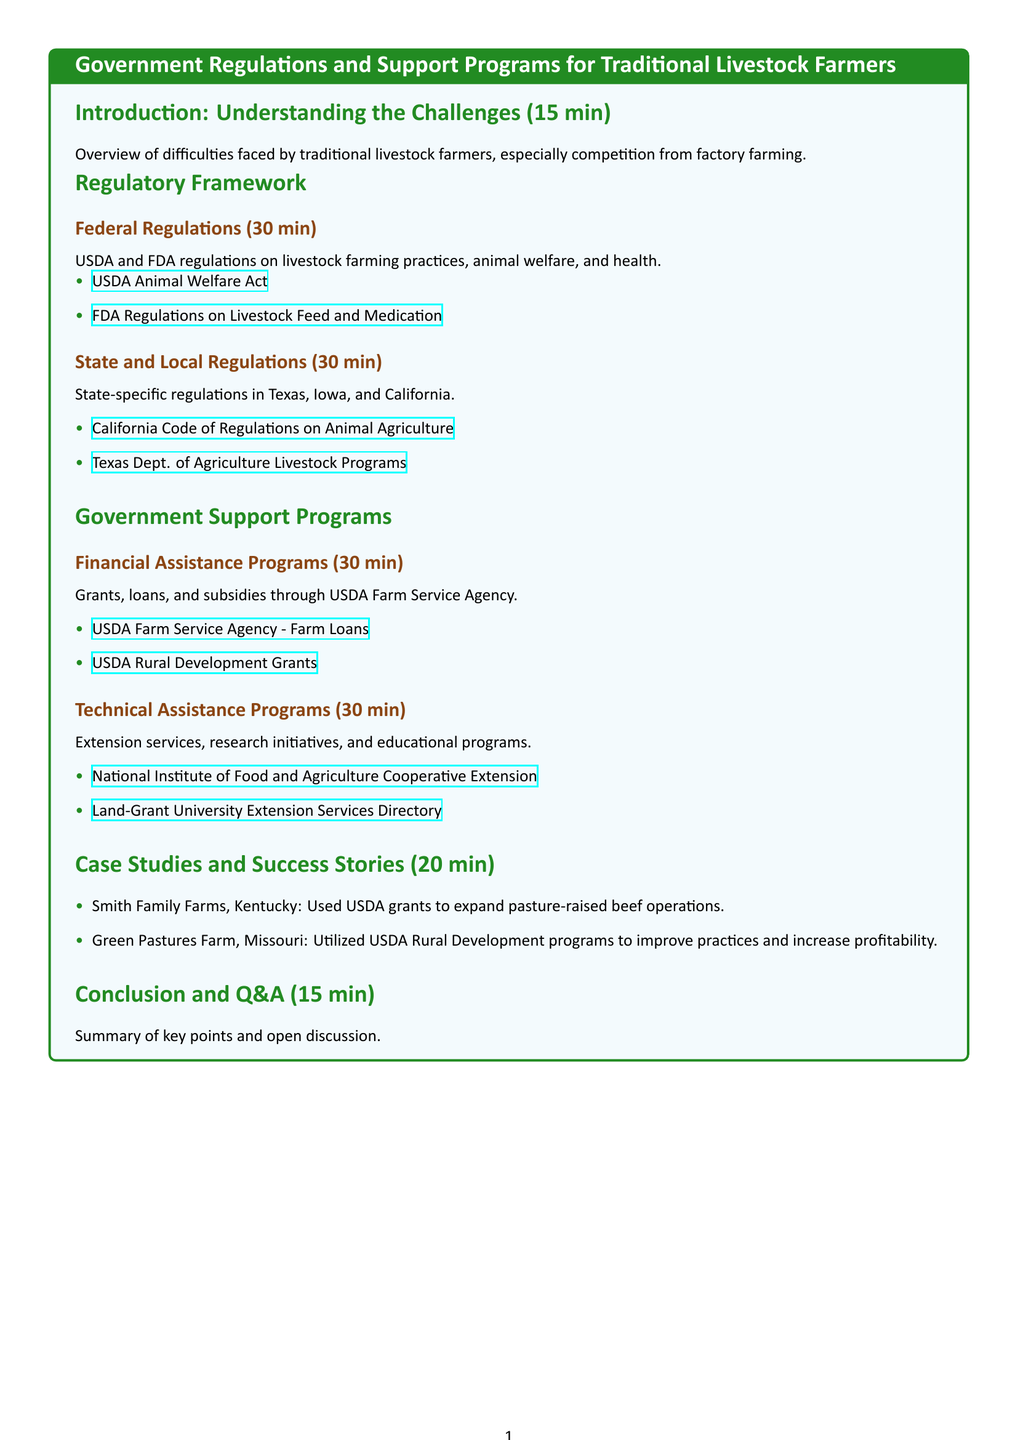What are the USDA regulations on livestock farming? This refers to the USDA regulations mentioned in the document under the Federal Regulations section.
Answer: USDA Animal Welfare Act What types of assistance does the USDA Farm Service Agency provide? The document lists financial assistance programs under the Government Support Programs section from the USDA Farm Service Agency.
Answer: Grants, loans, and subsidies Which state-specific regulations are mentioned for Texas? This would be found in the State and Local Regulations subsection regarding Texas.
Answer: Texas Dept. of Agriculture Livestock Programs How long is the introduction section of the syllabus? The time allocated is mentioned in the Introduction section.
Answer: 15 min What case study demonstrates the use of USDA grants in Kentucky? The document lists a specific case study in the Case Studies section regarding Kentucky.
Answer: Smith Family Farms, Kentucky What type of program is offered by the National Institute of Food and Agriculture? The program details pertain to the Technical Assistance Programs provided.
Answer: Cooperative Extension How much time is allocated for the conclusion and Q&A? The allocated time for this part is directly mentioned in the Conclusion section.
Answer: 15 min Which farm improved its practices using USDA Rural Development programs? This information can be found in the specific case studies listed in the document.
Answer: Green Pastures Farm, Missouri What is the overall theme of the syllabus? The overall theme is described in the title of the document.
Answer: Government Regulations and Support Programs for Traditional Livestock Farmers 